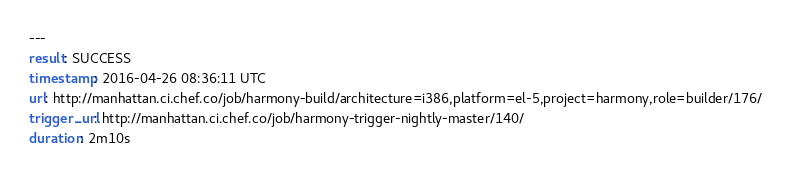<code> <loc_0><loc_0><loc_500><loc_500><_YAML_>---
result: SUCCESS
timestamp: 2016-04-26 08:36:11 UTC
url: http://manhattan.ci.chef.co/job/harmony-build/architecture=i386,platform=el-5,project=harmony,role=builder/176/
trigger_url: http://manhattan.ci.chef.co/job/harmony-trigger-nightly-master/140/
duration: 2m10s
</code> 